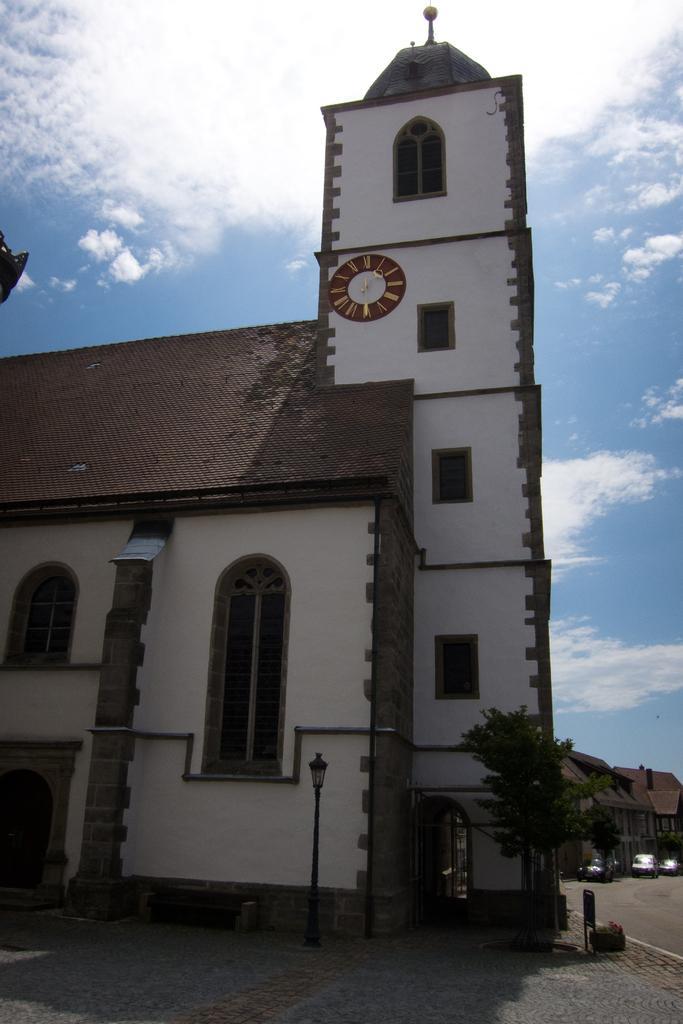In one or two sentences, can you explain what this image depicts? In this image I can see a building in cream and brown color. I can also see few trees in green color and sky in blue and white color. 